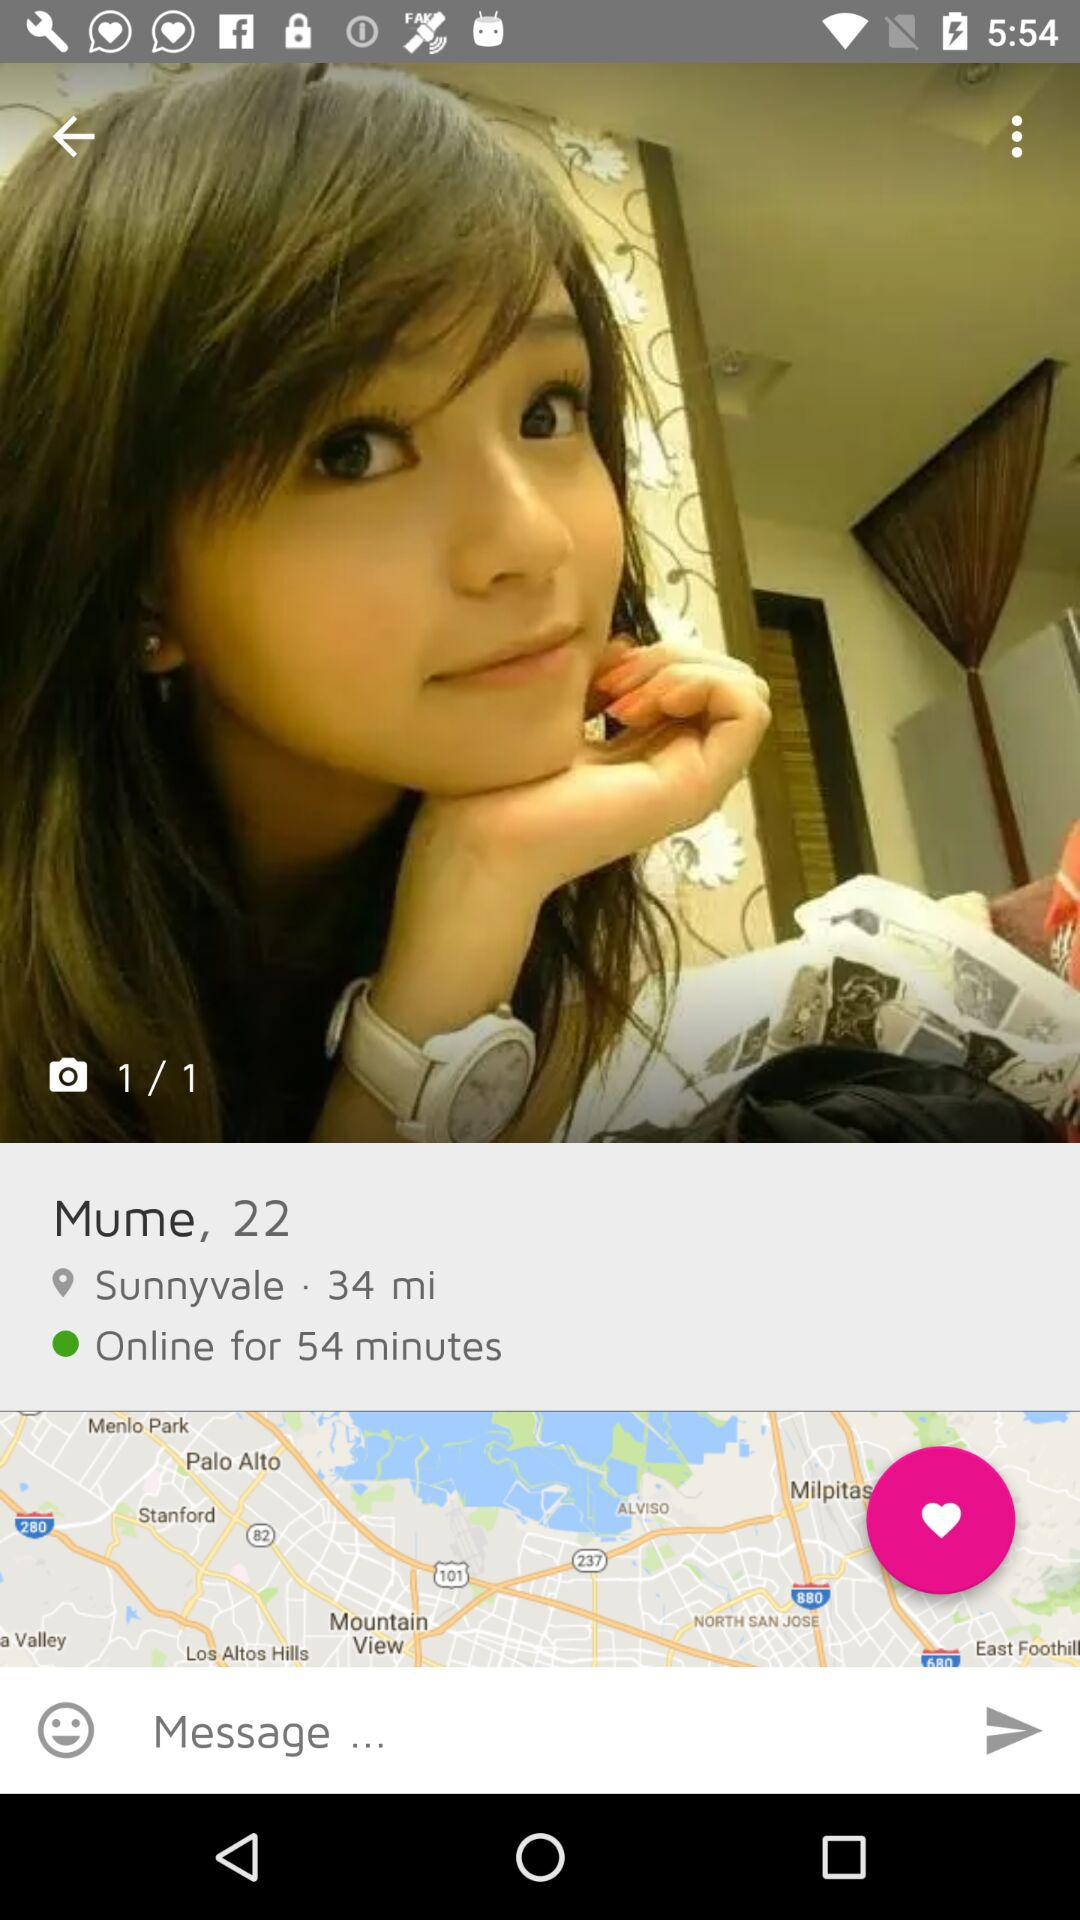What is the name? The name is Mume. 